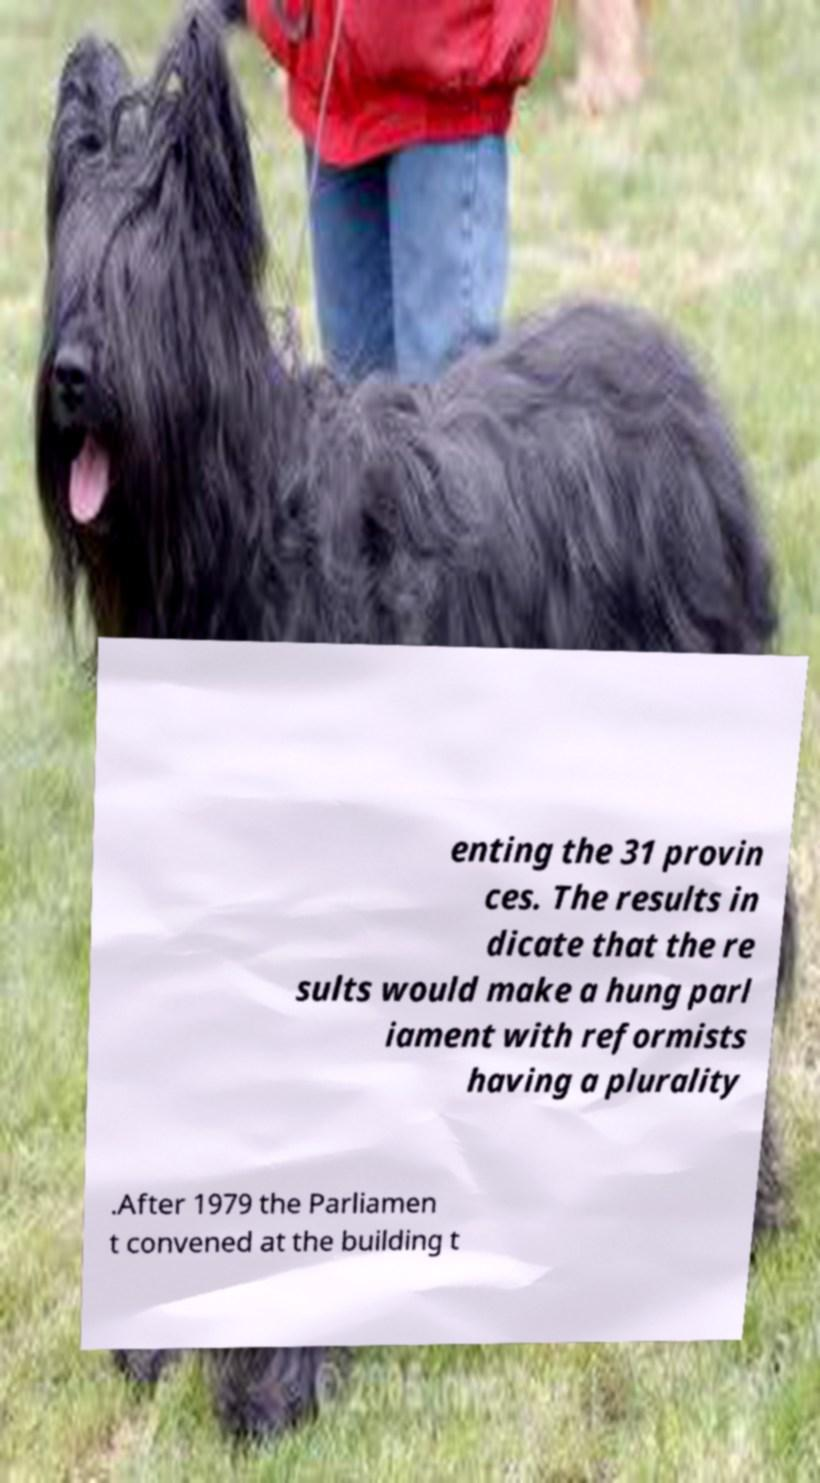There's text embedded in this image that I need extracted. Can you transcribe it verbatim? enting the 31 provin ces. The results in dicate that the re sults would make a hung parl iament with reformists having a plurality .After 1979 the Parliamen t convened at the building t 